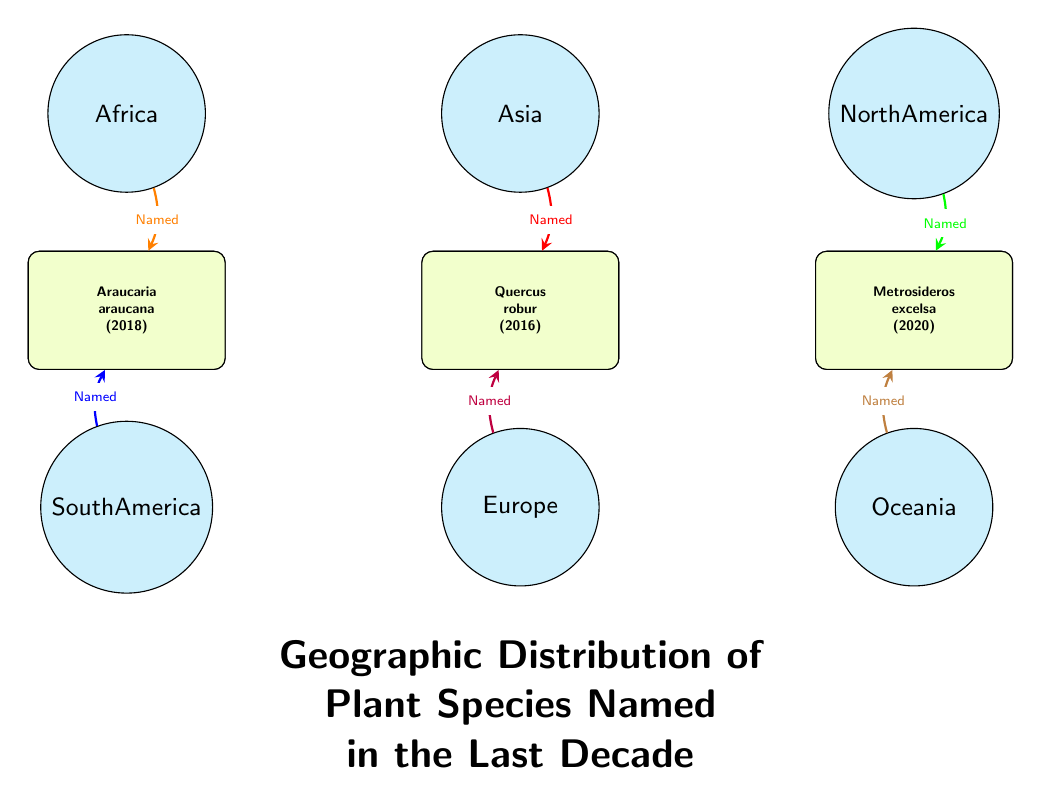What species was named in Africa? The diagram shows the species named in Africa, which is represented by the node "Hibiscus rosa-sinensis (2014)".
Answer: Hibiscus rosa-sinensis (2014) How many species are named in total? The diagram displays six species nodes connected to six regions, indicating that there are six species named in total.
Answer: 6 Which region is associated with the species Araucaria? The diagram connects the species Araucaria araucana to South America, indicated by its position below that region.
Answer: South America What color represents species named in Asia? In the diagram, the arrow leading from Asia to the node Cassia javanica is colored red, identifying it as the representation for species names from Asia.
Answer: Red Which species from Oceania was named most recently? The diagram shows that the species Metrosideros excelsa (2020) is the only species listed from Oceania and is also the most recently named among the species presented.
Answer: Metrosideros excelsa (2020) Which region has the species that includes the word "robur"? The diagram directly connects the species Quercus robur to Europe through the labeled arrow, indicating its association with that region.
Answer: Europe Which two regions are linked to a species named in 2019? The arrows leading to the species Washingtonia filifera (2019) connect from North America, indicating that it is the only species named in that year and linked to that specific region.
Answer: North America What species of plant was named in 2016? The diagram clearly shows the name Quercus robur (2016) associated with the Europe region.
Answer: Quercus robur (2016) How many regions are represented in the diagram? The diagram illustrates six distinct regions, each represented by a circular node.
Answer: 6 